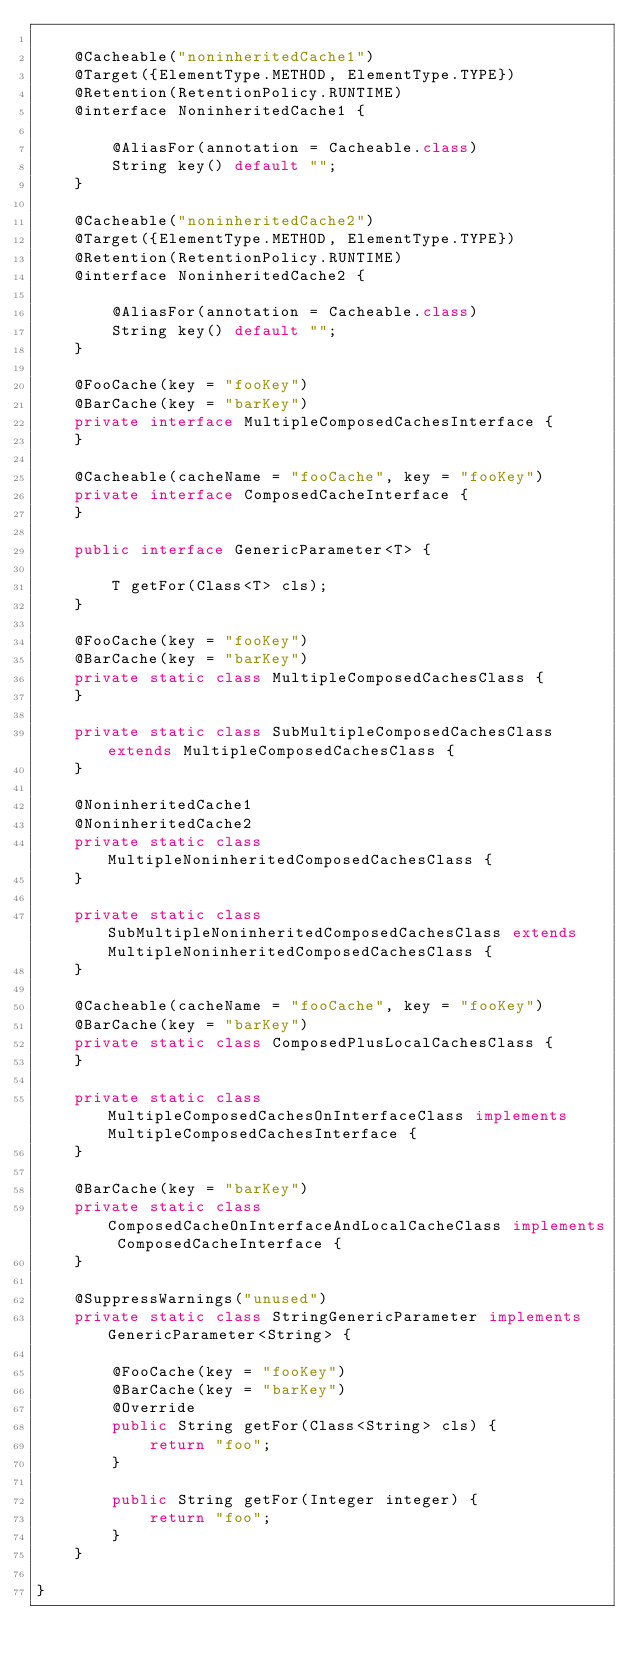<code> <loc_0><loc_0><loc_500><loc_500><_Java_>
    @Cacheable("noninheritedCache1")
    @Target({ElementType.METHOD, ElementType.TYPE})
    @Retention(RetentionPolicy.RUNTIME)
    @interface NoninheritedCache1 {

        @AliasFor(annotation = Cacheable.class)
        String key() default "";
    }

    @Cacheable("noninheritedCache2")
    @Target({ElementType.METHOD, ElementType.TYPE})
    @Retention(RetentionPolicy.RUNTIME)
    @interface NoninheritedCache2 {

        @AliasFor(annotation = Cacheable.class)
        String key() default "";
    }

    @FooCache(key = "fooKey")
    @BarCache(key = "barKey")
    private interface MultipleComposedCachesInterface {
    }

    @Cacheable(cacheName = "fooCache", key = "fooKey")
    private interface ComposedCacheInterface {
    }

    public interface GenericParameter<T> {

        T getFor(Class<T> cls);
    }

    @FooCache(key = "fooKey")
    @BarCache(key = "barKey")
    private static class MultipleComposedCachesClass {
    }

    private static class SubMultipleComposedCachesClass extends MultipleComposedCachesClass {
    }

    @NoninheritedCache1
    @NoninheritedCache2
    private static class MultipleNoninheritedComposedCachesClass {
    }

    private static class SubMultipleNoninheritedComposedCachesClass extends MultipleNoninheritedComposedCachesClass {
    }

    @Cacheable(cacheName = "fooCache", key = "fooKey")
    @BarCache(key = "barKey")
    private static class ComposedPlusLocalCachesClass {
    }

    private static class MultipleComposedCachesOnInterfaceClass implements MultipleComposedCachesInterface {
    }

    @BarCache(key = "barKey")
    private static class ComposedCacheOnInterfaceAndLocalCacheClass implements ComposedCacheInterface {
    }

    @SuppressWarnings("unused")
    private static class StringGenericParameter implements GenericParameter<String> {

        @FooCache(key = "fooKey")
        @BarCache(key = "barKey")
        @Override
        public String getFor(Class<String> cls) {
            return "foo";
        }

        public String getFor(Integer integer) {
            return "foo";
        }
    }

}
</code> 